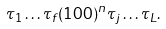Convert formula to latex. <formula><loc_0><loc_0><loc_500><loc_500>\tau _ { 1 } \dots \tau _ { f } ( 1 0 0 ) ^ { n } \tau _ { j } \dots \tau _ { L } .</formula> 